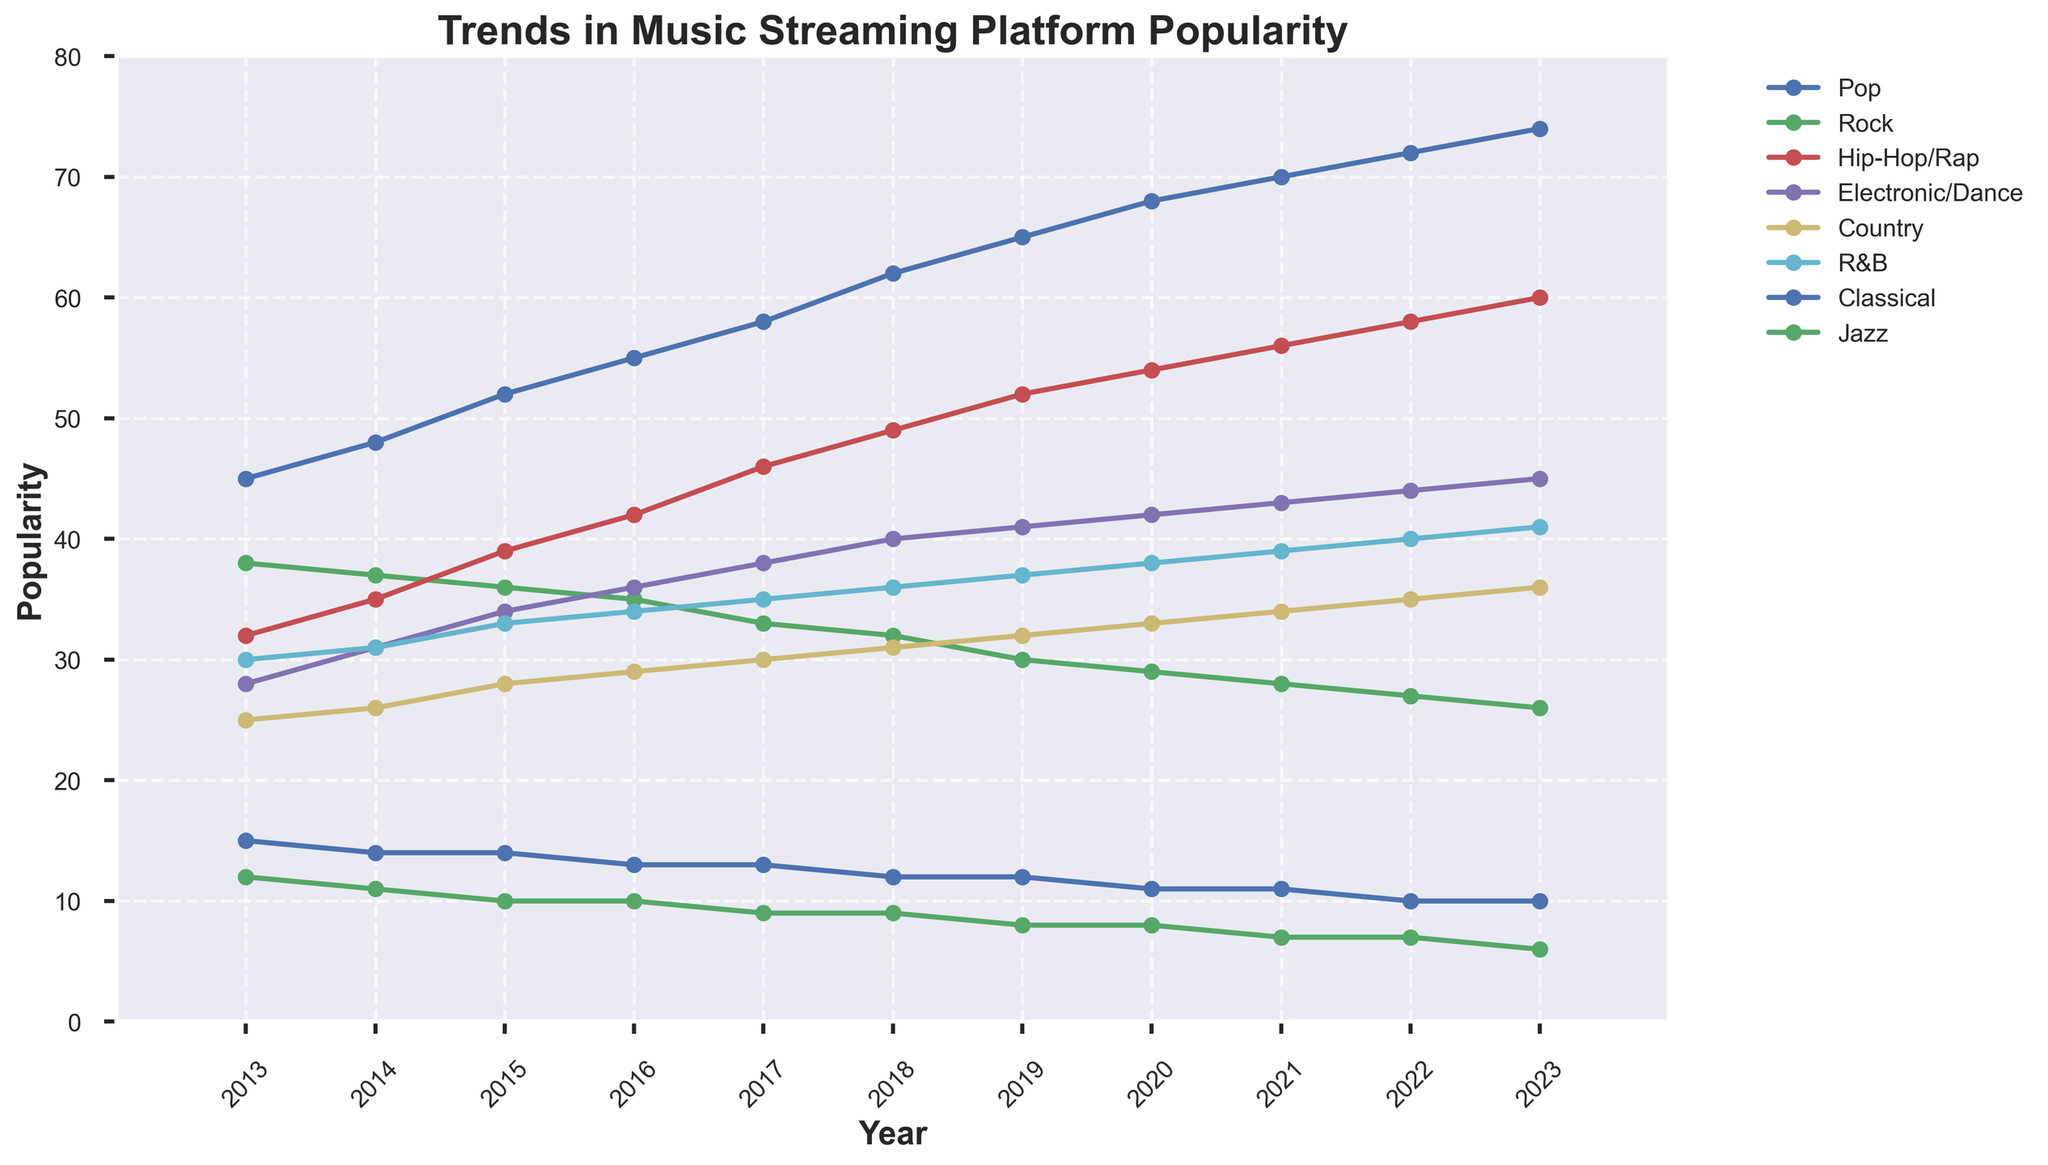What genre showed the greatest increase in popularity from 2013 to 2023? To find the genre with the greatest increase, look at the difference between the values in 2023 and 2013 for each genre. Hip-Hop/Rap increased from 32 to 60, which is a change of 28, more than any other genre.
Answer: Hip-Hop/Rap Between which consecutive years did Pop music see the largest increase in popularity? Examine the year-to-year increases in Pop's popularity. The biggest jump is from 2017 (58) to 2018 (62), an increase of 4 points.
Answer: 2017 to 2018 What is the average popularity of Country music over the decade? Add the popularity values of Country music for each year from 2013 to 2023, then divide by the number of years (11). The sum is 335, and 335/11 gives an average of approximately 30.45.
Answer: 30.45 Which genre's popularity dropped the most from 2013 to 2023? Determine the decline for each genre by subtracting the 2023 value from the 2013 value. Rock's popularity dropped from 38 to 26, a reduction of 12, which is the largest drop.
Answer: Rock In which year did Electronic/Dance first surpass Rock in popularity? Compare the values for Electronic/Dance and Rock year by year. In 2015, Electronic/Dance (34) surpassed Rock (36) for the first time.
Answer: 2015 By how much did R&B's popularity increase from 2015 to 2023? Subtract R&B's 2015 popularity (33) from its 2023 popularity (41) to find the increase, which is 8.
Answer: 8 Which genre was more popular in 2020, Classical or Jazz? Compare Classical's popularity (11) and Jazz's popularity (8) for the year 2020. Classical was more popular.
Answer: Classical What is the trend in popularity for Pop music from 2013 to 2023? Look at the data for Pop music over the years. The popularity consistently increased every year from 45 in 2013 to 74 in 2023.
Answer: Increasing Which genre showed a steady decline over the decade? Analyze the trends for each genre. Rock shows a steady decline every year from 38 in 2013 to 26 in 2023.
Answer: Rock Was there any genre with a flat popularity trend throughout the decade? Check each genre's values year by year. No genre maintained a completely flat trend; all saw some change.
Answer: No 